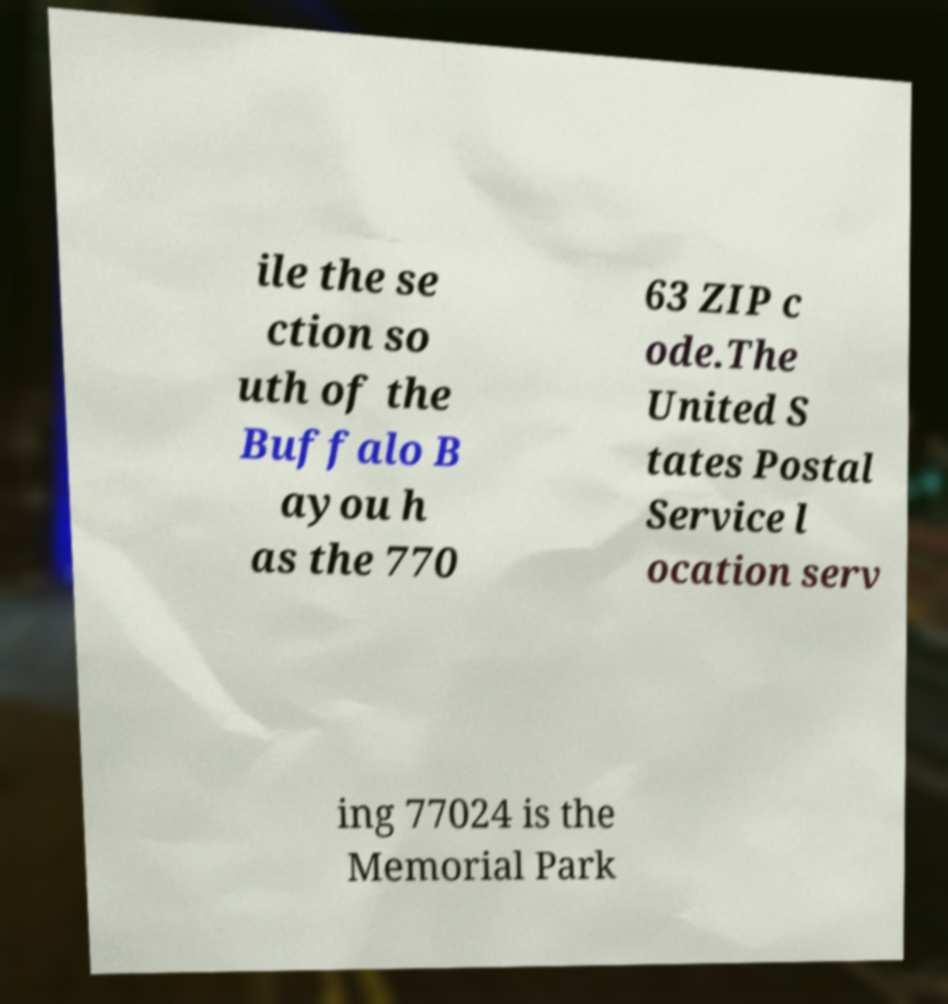Can you read and provide the text displayed in the image?This photo seems to have some interesting text. Can you extract and type it out for me? ile the se ction so uth of the Buffalo B ayou h as the 770 63 ZIP c ode.The United S tates Postal Service l ocation serv ing 77024 is the Memorial Park 